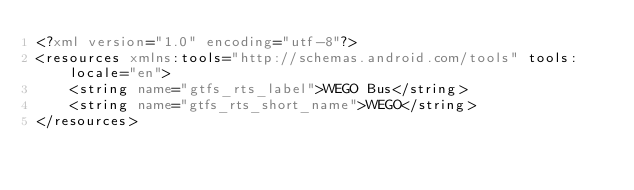<code> <loc_0><loc_0><loc_500><loc_500><_XML_><?xml version="1.0" encoding="utf-8"?>
<resources xmlns:tools="http://schemas.android.com/tools" tools:locale="en">
    <string name="gtfs_rts_label">WEGO Bus</string>
    <string name="gtfs_rts_short_name">WEGO</string>
</resources></code> 